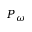<formula> <loc_0><loc_0><loc_500><loc_500>P _ { \omega }</formula> 